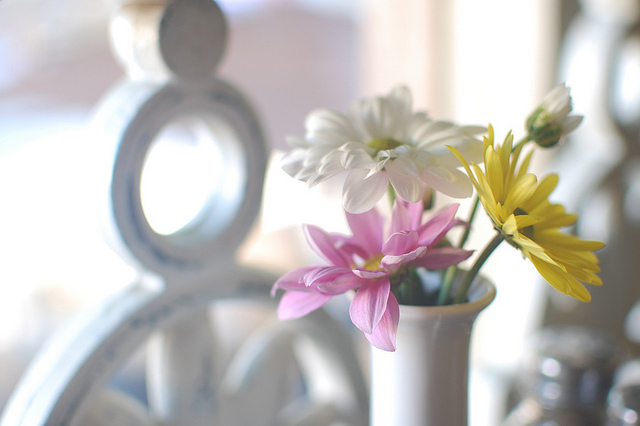<image>Is this location a restaurant? I don't know if it is a restaurant. It could either be a restaurant or not. Is this location a restaurant? I am not sure if this location is a restaurant. It can be both a restaurant or not. 